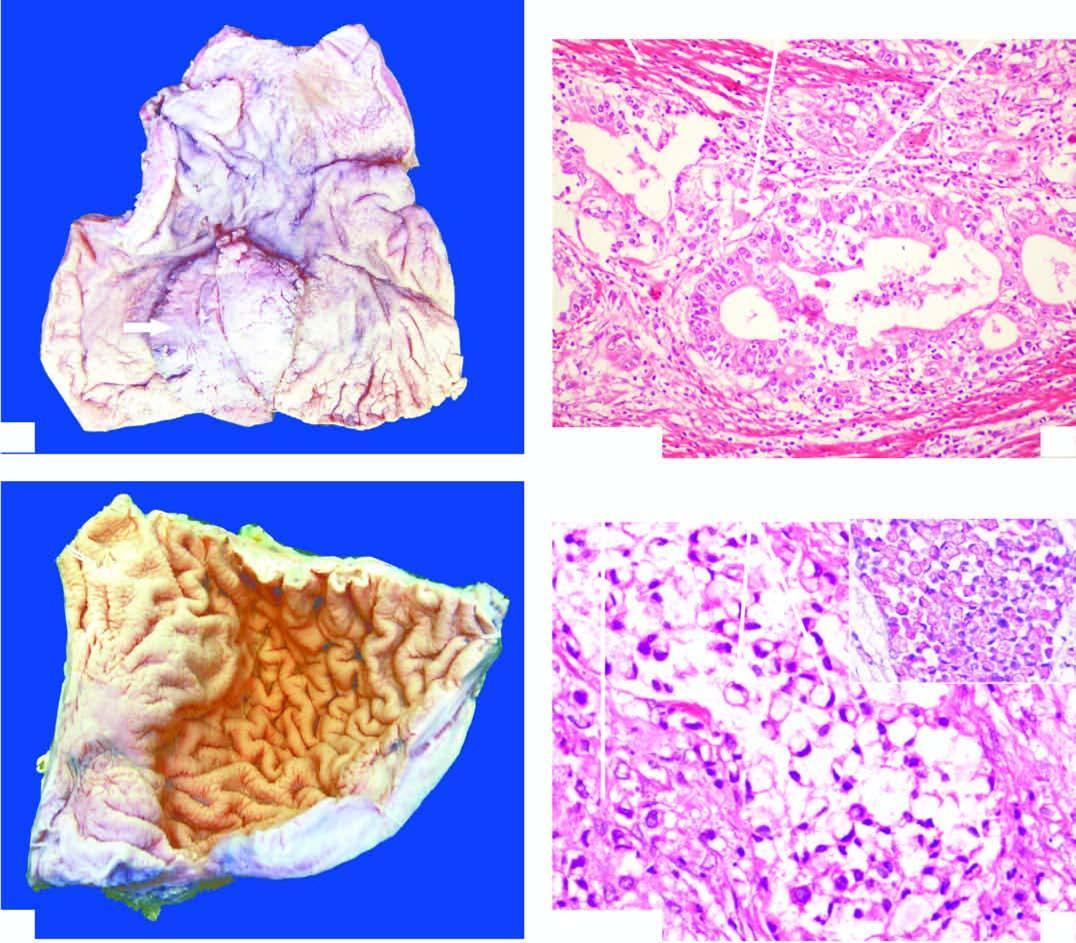what are malignant cells forming irregular glands with?
Answer the question using a single word or phrase. Stratification wall 